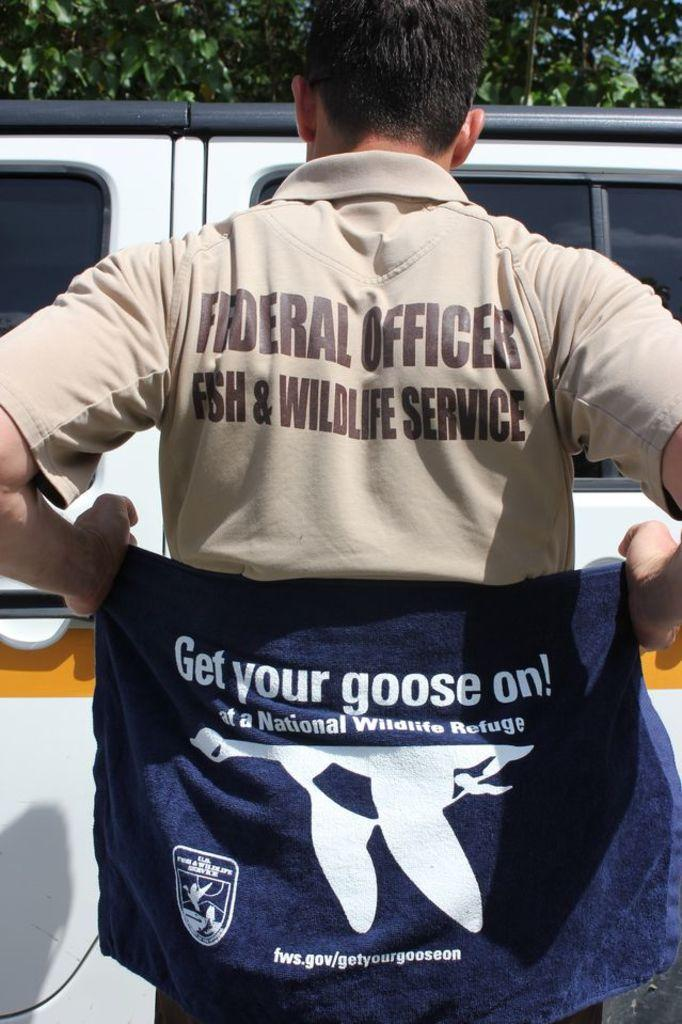<image>
Summarize the visual content of the image. Man holding a towel which says "Get your goose on". 